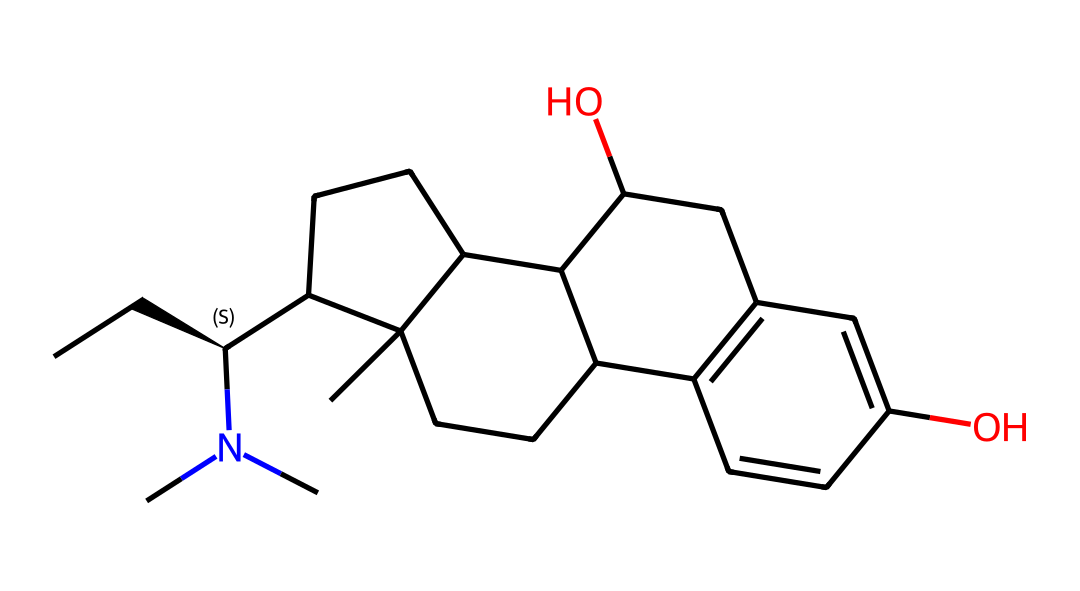What is the total number of carbon atoms in this structure? To find the total number of carbon atoms, count each carbon symbol (C) present in the structure. There are 19 carbon atoms represented in the SMILES notation.
Answer: 19 How many nitrogen atoms are present in the chemical? The nitrogen atom is represented by the symbol N in the SMILES notation. There is one nitrogen atom observed in the structure.
Answer: 1 Which functional group is indicated by the presence of the "O" atoms in this structure? The "O" atoms signify hydroxyl groups (–OH), which are functional groups that indicate the presence of alcohols in this molecule. There are two hydroxyl groups indicated in the structure.
Answer: hydroxyl What type of chemical compound does this structure represent? This compound is classified as an alkaloid based on the structure featuring a nitrogen atom (N), which is a characteristic of alkaloids.
Answer: alkaloid Does this chemical contain any stereocenters? The notation "@@" implies the presence of stereochemistry, indicating that there is indeed a stereocenter in this structure. The specific "@@" notation shows the configuration of the carbon atom at that position.
Answer: yes What are the implications of the hydroxyl groups on the solubility of this compound? Hydroxyl groups enhance the polarity of the molecule, which generally increases its solubility in water due to hydrogen bonding capabilities with water.
Answer: increased solubility What historical significance does Mandrake root have in medieval studies? Mandrake root was believed to possess magical properties and was often associated with various myths and medicinal practices in medieval times. Its historical use is tied to both folklore and pharmacology.
Answer: magical properties 